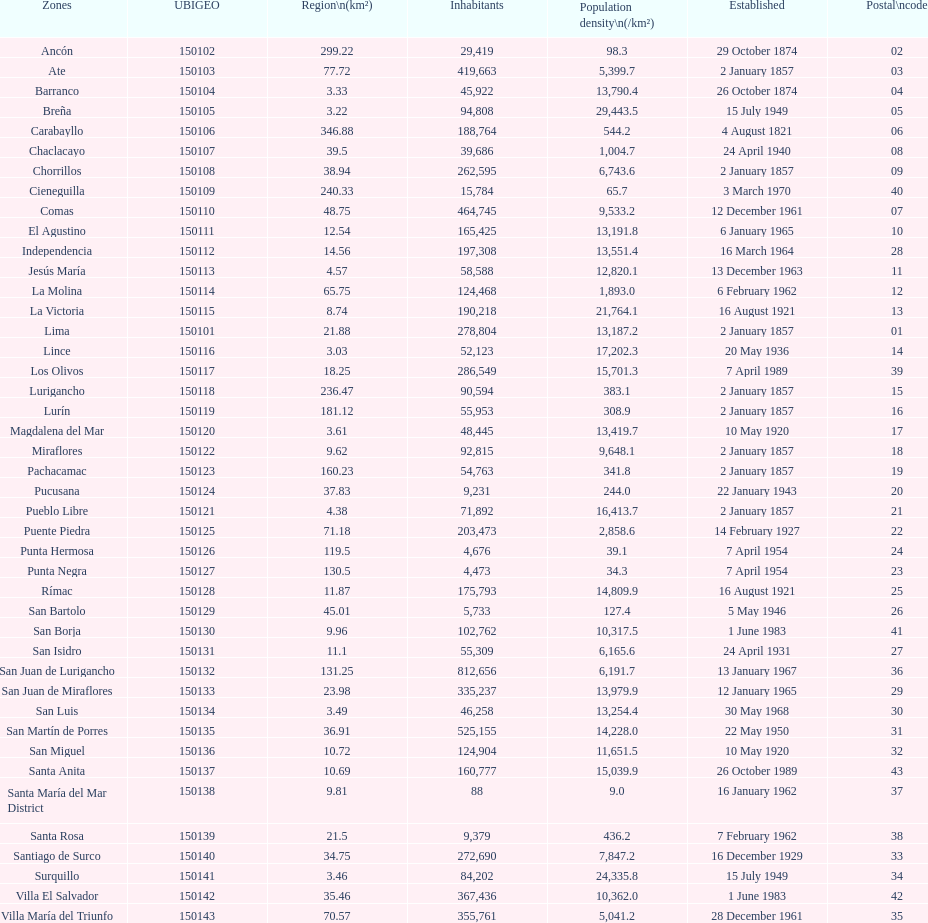What is the total number of districts created in the 1900's? 32. 